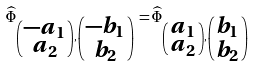<formula> <loc_0><loc_0><loc_500><loc_500>\widehat { \Phi } _ { \left ( \begin{smallmatrix} - a _ { 1 } \\ a _ { 2 } \end{smallmatrix} \right ) , \left ( \begin{smallmatrix} - b _ { 1 } \\ b _ { 2 } \end{smallmatrix} \right ) } = \widehat { \Phi } _ { \left ( \begin{smallmatrix} a _ { 1 } \\ a _ { 2 } \end{smallmatrix} \right ) , \left ( \begin{smallmatrix} b _ { 1 } \\ b _ { 2 } \end{smallmatrix} \right ) }</formula> 